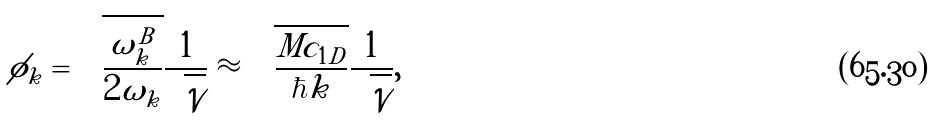<formula> <loc_0><loc_0><loc_500><loc_500>\phi _ { k } = \sqrt { \frac { \omega _ { k } ^ { B } } { 2 \omega _ { k } } } \frac { 1 } { \sqrt { \mathcal { V } } } \approx \sqrt { \frac { M c _ { 1 D } } { \hbar { k } } } \frac { 1 } { \sqrt { \mathcal { V } } } ,</formula> 